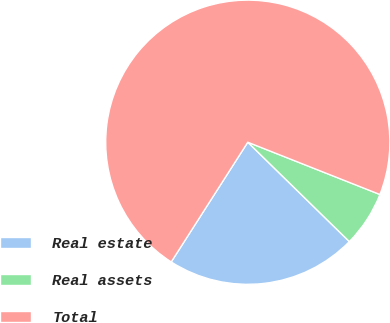Convert chart to OTSL. <chart><loc_0><loc_0><loc_500><loc_500><pie_chart><fcel>Real estate<fcel>Real assets<fcel>Total<nl><fcel>21.73%<fcel>6.33%<fcel>71.94%<nl></chart> 